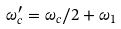Convert formula to latex. <formula><loc_0><loc_0><loc_500><loc_500>\omega _ { c } ^ { \prime } = \omega _ { c } / 2 + \omega _ { 1 }</formula> 